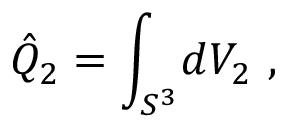Convert formula to latex. <formula><loc_0><loc_0><loc_500><loc_500>\hat { Q } _ { 2 } = \int _ { S ^ { 3 } } \, d V _ { 2 } \ ,</formula> 